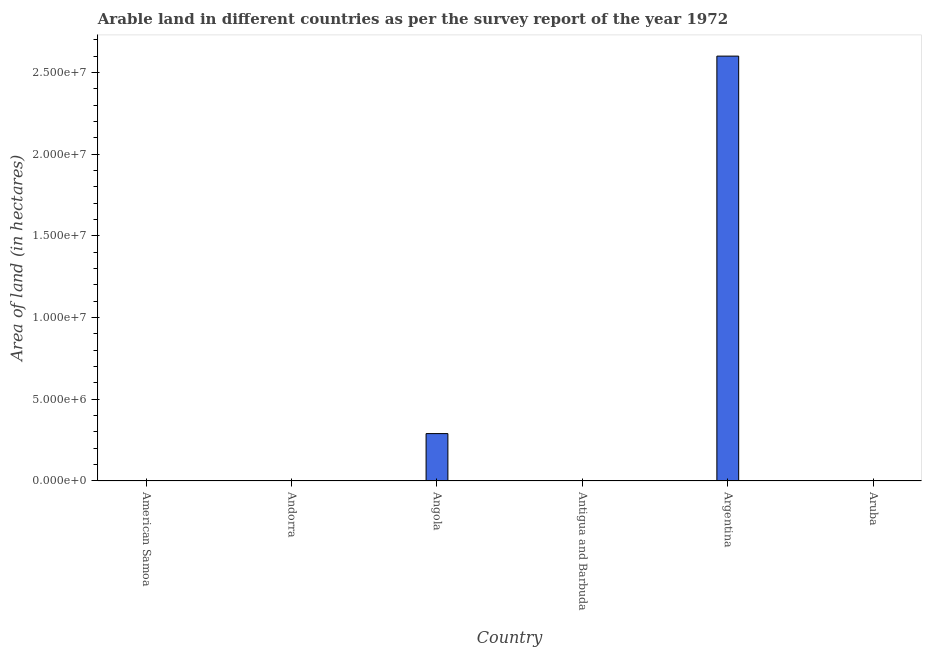What is the title of the graph?
Make the answer very short. Arable land in different countries as per the survey report of the year 1972. What is the label or title of the Y-axis?
Your answer should be very brief. Area of land (in hectares). What is the area of land in Argentina?
Offer a terse response. 2.60e+07. Across all countries, what is the maximum area of land?
Offer a terse response. 2.60e+07. Across all countries, what is the minimum area of land?
Provide a succinct answer. 1000. In which country was the area of land maximum?
Offer a very short reply. Argentina. In which country was the area of land minimum?
Your answer should be very brief. American Samoa. What is the sum of the area of land?
Give a very brief answer. 2.89e+07. What is the difference between the area of land in Angola and Antigua and Barbuda?
Provide a short and direct response. 2.90e+06. What is the average area of land per country?
Your answer should be very brief. 4.82e+06. What is the median area of land?
Your answer should be very brief. 2500. What is the ratio of the area of land in Andorra to that in Angola?
Your answer should be very brief. 0. What is the difference between the highest and the second highest area of land?
Keep it short and to the point. 2.31e+07. What is the difference between the highest and the lowest area of land?
Your answer should be compact. 2.60e+07. In how many countries, is the area of land greater than the average area of land taken over all countries?
Provide a short and direct response. 1. Are all the bars in the graph horizontal?
Ensure brevity in your answer.  No. What is the Area of land (in hectares) of American Samoa?
Your response must be concise. 1000. What is the Area of land (in hectares) in Andorra?
Make the answer very short. 1000. What is the Area of land (in hectares) of Angola?
Your answer should be compact. 2.90e+06. What is the Area of land (in hectares) of Antigua and Barbuda?
Offer a very short reply. 3000. What is the Area of land (in hectares) of Argentina?
Ensure brevity in your answer.  2.60e+07. What is the Area of land (in hectares) in Aruba?
Your response must be concise. 2000. What is the difference between the Area of land (in hectares) in American Samoa and Angola?
Offer a very short reply. -2.90e+06. What is the difference between the Area of land (in hectares) in American Samoa and Antigua and Barbuda?
Your answer should be compact. -2000. What is the difference between the Area of land (in hectares) in American Samoa and Argentina?
Offer a very short reply. -2.60e+07. What is the difference between the Area of land (in hectares) in American Samoa and Aruba?
Your response must be concise. -1000. What is the difference between the Area of land (in hectares) in Andorra and Angola?
Give a very brief answer. -2.90e+06. What is the difference between the Area of land (in hectares) in Andorra and Antigua and Barbuda?
Your answer should be very brief. -2000. What is the difference between the Area of land (in hectares) in Andorra and Argentina?
Provide a succinct answer. -2.60e+07. What is the difference between the Area of land (in hectares) in Andorra and Aruba?
Your answer should be compact. -1000. What is the difference between the Area of land (in hectares) in Angola and Antigua and Barbuda?
Offer a very short reply. 2.90e+06. What is the difference between the Area of land (in hectares) in Angola and Argentina?
Offer a very short reply. -2.31e+07. What is the difference between the Area of land (in hectares) in Angola and Aruba?
Your answer should be compact. 2.90e+06. What is the difference between the Area of land (in hectares) in Antigua and Barbuda and Argentina?
Offer a terse response. -2.60e+07. What is the difference between the Area of land (in hectares) in Argentina and Aruba?
Keep it short and to the point. 2.60e+07. What is the ratio of the Area of land (in hectares) in American Samoa to that in Andorra?
Give a very brief answer. 1. What is the ratio of the Area of land (in hectares) in American Samoa to that in Antigua and Barbuda?
Provide a short and direct response. 0.33. What is the ratio of the Area of land (in hectares) in American Samoa to that in Argentina?
Provide a succinct answer. 0. What is the ratio of the Area of land (in hectares) in Andorra to that in Antigua and Barbuda?
Offer a terse response. 0.33. What is the ratio of the Area of land (in hectares) in Andorra to that in Argentina?
Provide a succinct answer. 0. What is the ratio of the Area of land (in hectares) in Andorra to that in Aruba?
Offer a very short reply. 0.5. What is the ratio of the Area of land (in hectares) in Angola to that in Antigua and Barbuda?
Give a very brief answer. 966.67. What is the ratio of the Area of land (in hectares) in Angola to that in Argentina?
Keep it short and to the point. 0.11. What is the ratio of the Area of land (in hectares) in Angola to that in Aruba?
Your response must be concise. 1450. What is the ratio of the Area of land (in hectares) in Antigua and Barbuda to that in Argentina?
Your response must be concise. 0. What is the ratio of the Area of land (in hectares) in Antigua and Barbuda to that in Aruba?
Give a very brief answer. 1.5. What is the ratio of the Area of land (in hectares) in Argentina to that in Aruba?
Your response must be concise. 1.30e+04. 